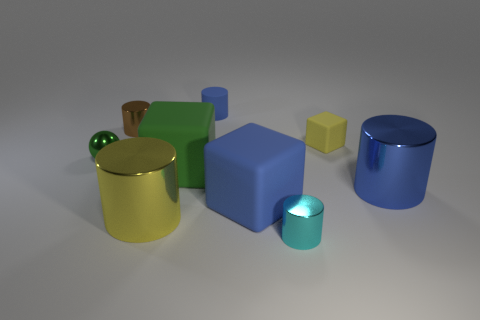Is the number of blue rubber cylinders less than the number of large red matte cylinders?
Your answer should be compact. No. Are there any green objects that have the same material as the tiny cyan cylinder?
Provide a succinct answer. Yes. There is a big blue thing to the right of the tiny cube; what shape is it?
Offer a very short reply. Cylinder. Does the small cylinder that is to the left of the large yellow cylinder have the same color as the small shiny sphere?
Your response must be concise. No. Is the number of matte things behind the green rubber cube less than the number of tiny yellow matte blocks?
Provide a succinct answer. No. The small ball that is the same material as the small brown object is what color?
Give a very brief answer. Green. There is a blue matte thing that is on the left side of the blue rubber cube; what size is it?
Give a very brief answer. Small. Is the material of the cyan thing the same as the large yellow cylinder?
Offer a terse response. Yes. Is there a big blue rubber thing that is in front of the blue rubber thing that is in front of the blue thing behind the tiny brown cylinder?
Offer a terse response. No. The small sphere is what color?
Provide a short and direct response. Green. 